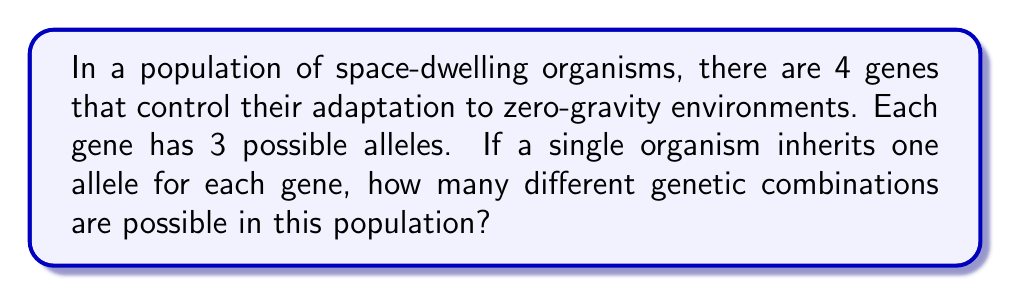What is the answer to this math problem? To solve this problem, we need to apply the fundamental counting principle from combinatorics. Let's break it down step-by-step:

1. We have 4 genes, each with 3 possible alleles.

2. For each gene, the organism must inherit exactly one allele.

3. The choices for each gene are independent of the others.

4. According to the fundamental counting principle, when we have a series of independent choices, we multiply the number of possibilities for each choice.

5. In this case, we have:
   - 3 choices for the first gene
   - 3 choices for the second gene
   - 3 choices for the third gene
   - 3 choices for the fourth gene

6. Therefore, the total number of possible genetic combinations is:

   $$3 \times 3 \times 3 \times 3 = 3^4$$

7. Calculate the result:
   $$3^4 = 81$$

Thus, there are 81 possible genetic combinations in this population of space-dwelling organisms.
Answer: $3^4 = 81$ combinations 